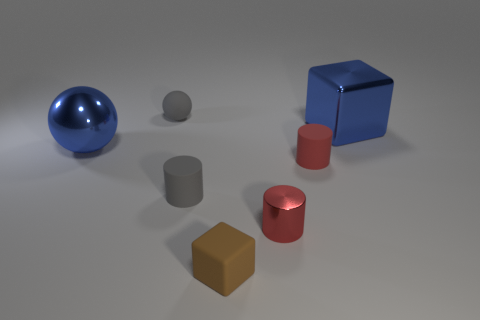Subtract all small shiny cylinders. How many cylinders are left? 2 Subtract all cylinders. How many objects are left? 4 Add 3 shiny things. How many objects exist? 10 Subtract all blue cubes. How many cubes are left? 1 Subtract 2 cylinders. How many cylinders are left? 1 Add 7 tiny matte balls. How many tiny matte balls are left? 8 Add 3 tiny red things. How many tiny red things exist? 5 Subtract 0 red spheres. How many objects are left? 7 Subtract all gray cylinders. Subtract all yellow cubes. How many cylinders are left? 2 Subtract all yellow spheres. How many brown cubes are left? 1 